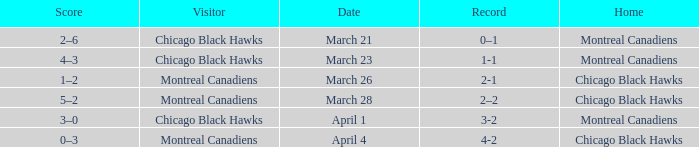What is the tally for the squad with a 2-1 record? 1–2. 